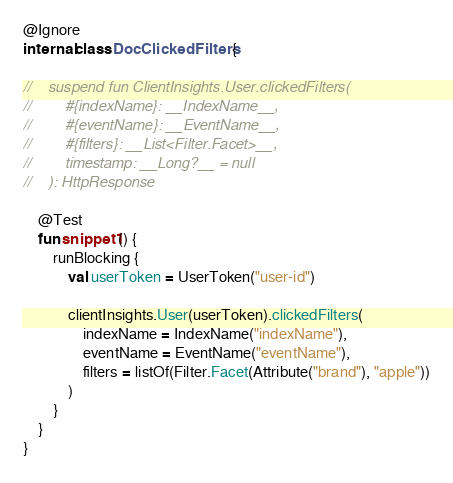<code> <loc_0><loc_0><loc_500><loc_500><_Kotlin_>
@Ignore
internal class DocClickedFilters {

//    suspend fun ClientInsights.User.clickedFilters(
//        #{indexName}: __IndexName__,
//        #{eventName}: __EventName__,
//        #{filters}: __List<Filter.Facet>__,
//        timestamp: __Long?__ = null
//    ): HttpResponse

    @Test
    fun snippet1() {
        runBlocking {
            val userToken = UserToken("user-id")

            clientInsights.User(userToken).clickedFilters(
                indexName = IndexName("indexName"),
                eventName = EventName("eventName"),
                filters = listOf(Filter.Facet(Attribute("brand"), "apple"))
            )
        }
    }
}
</code> 